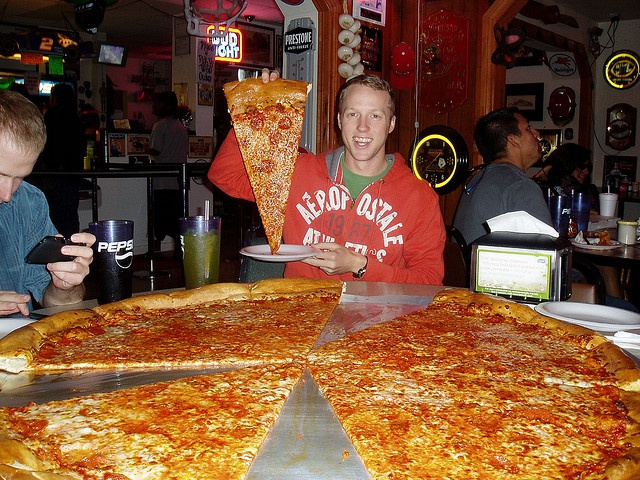Describe the objects in this image and their specific colors. I can see pizza in black, red, maroon, and orange tones, people in black, brown, red, and tan tones, pizza in black, orange, red, and tan tones, pizza in black, brown, maroon, and tan tones, and people in black, blue, tan, and gray tones in this image. 